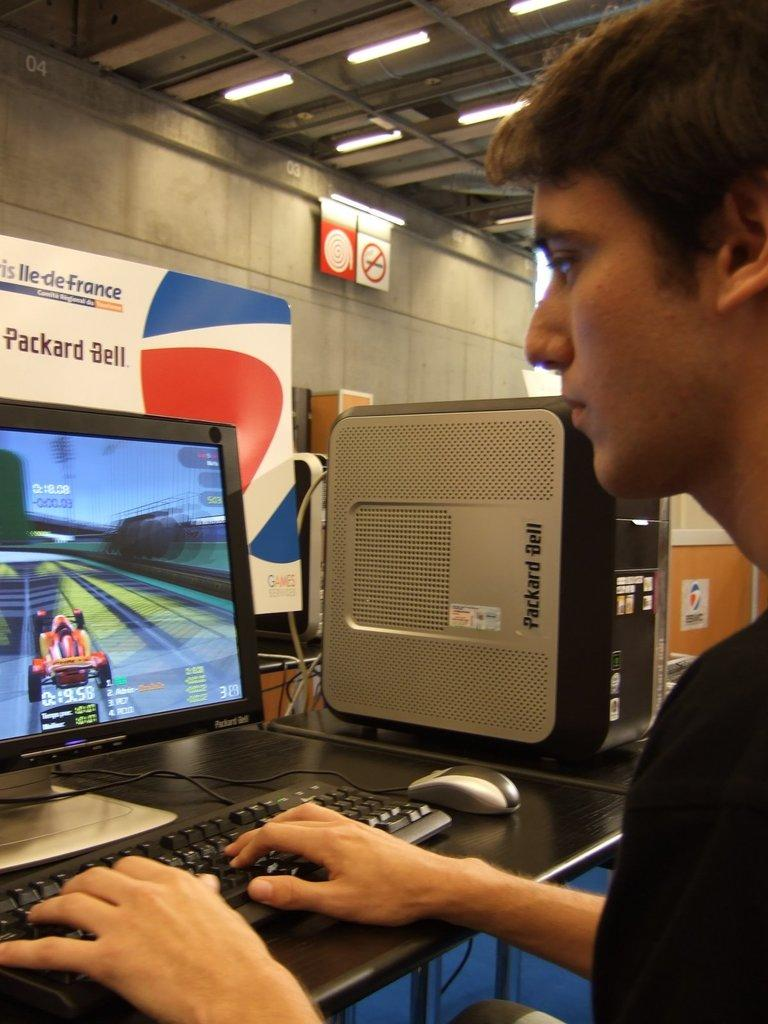<image>
Describe the image concisely. A teen male sitting in front of a computer, playing a racing game on a Packard Bell computer. 